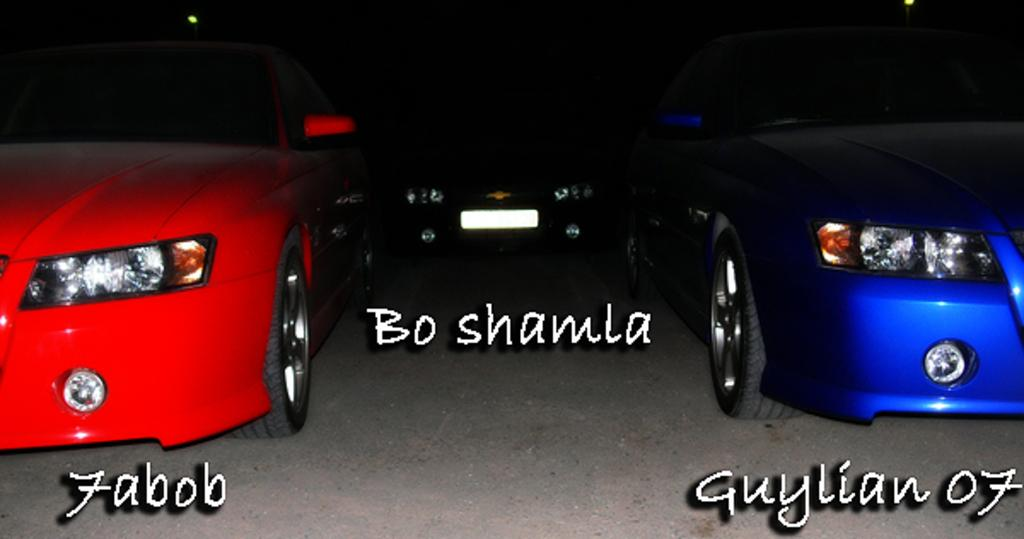How many cars are visible in the foreground of the image? There are three cars in the foreground of the image. Can you describe the positioning of the cars? One car is on the left side, one car is in the middle, and one car is on the right side. What is written at the bottom of the cars? There is text written at the bottom of the cars. What type of structure can be seen in the background of the image? There is no structure visible in the background of the image. What reason might the cars be parked in this specific arrangement? The reason for the cars' arrangement cannot be determined from the image alone. How many horses are present in the image? There are no horses present in the image. 